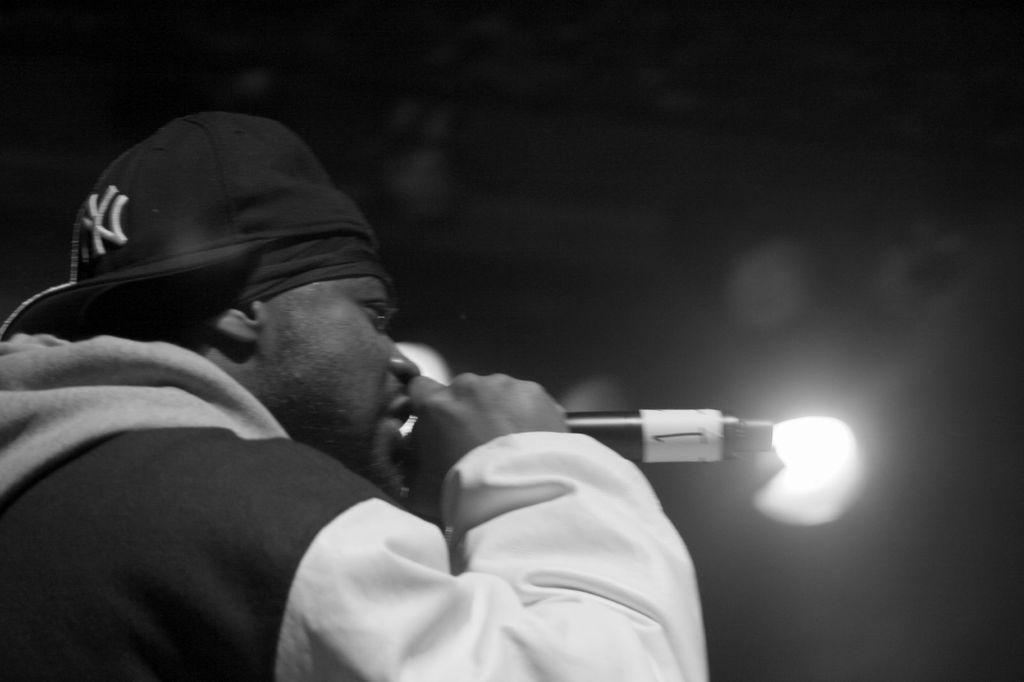Describe this image in one or two sentences. In this image i can see a person wearing a hat and a jacket is holding a microphone in his hand. In the background i can see a light and the black background. 